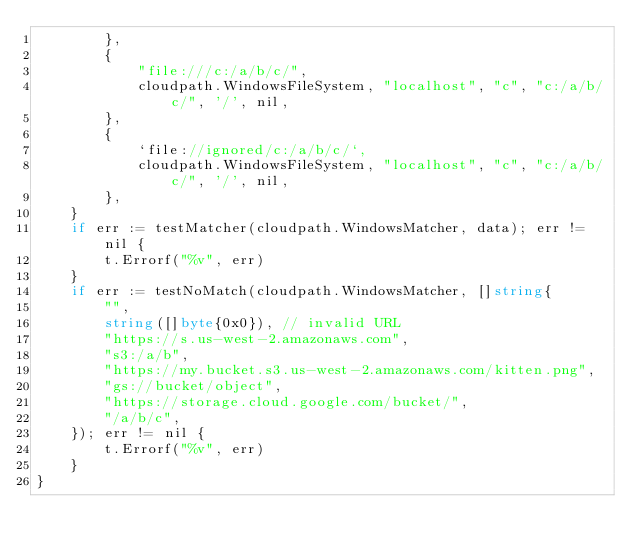Convert code to text. <code><loc_0><loc_0><loc_500><loc_500><_Go_>		},
		{
			"file:///c:/a/b/c/",
			cloudpath.WindowsFileSystem, "localhost", "c", "c:/a/b/c/", '/', nil,
		},
		{
			`file://ignored/c:/a/b/c/`,
			cloudpath.WindowsFileSystem, "localhost", "c", "c:/a/b/c/", '/', nil,
		},
	}
	if err := testMatcher(cloudpath.WindowsMatcher, data); err != nil {
		t.Errorf("%v", err)
	}
	if err := testNoMatch(cloudpath.WindowsMatcher, []string{
		"",
		string([]byte{0x0}), // invalid URL
		"https://s.us-west-2.amazonaws.com",
		"s3:/a/b",
		"https://my.bucket.s3.us-west-2.amazonaws.com/kitten.png",
		"gs://bucket/object",
		"https://storage.cloud.google.com/bucket/",
		"/a/b/c",
	}); err != nil {
		t.Errorf("%v", err)
	}
}
</code> 